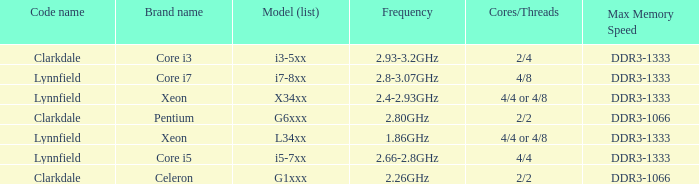What brand is model I7-8xx? Core i7. 